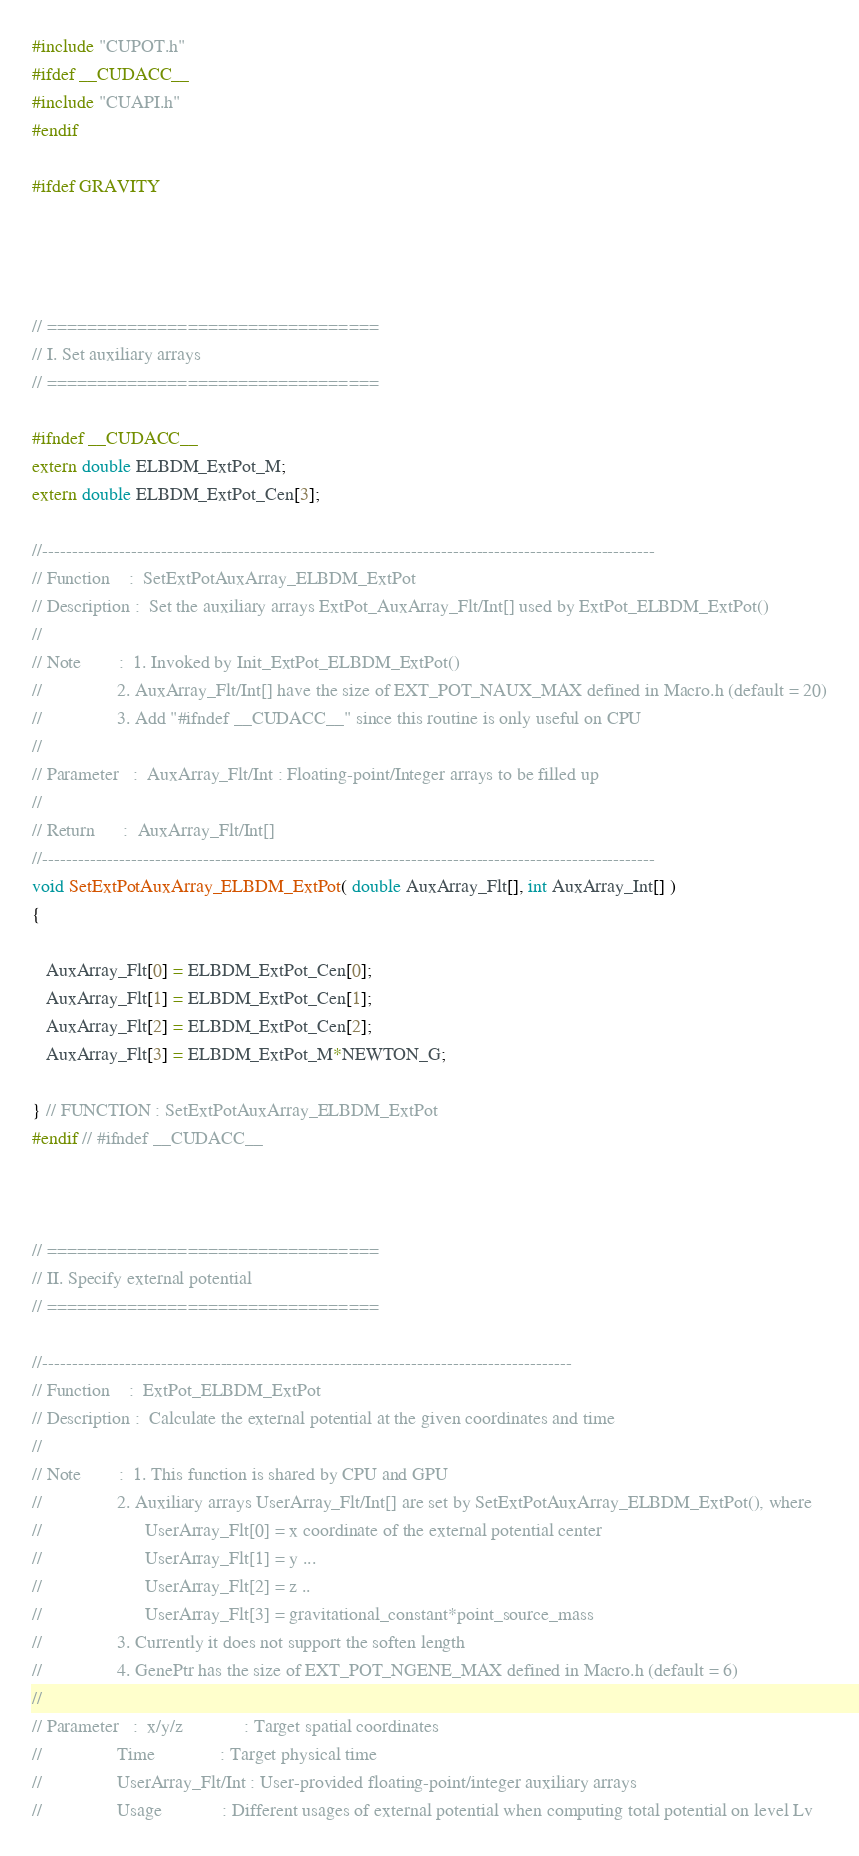Convert code to text. <code><loc_0><loc_0><loc_500><loc_500><_Cuda_>#include "CUPOT.h"
#ifdef __CUDACC__
#include "CUAPI.h"
#endif

#ifdef GRAVITY




// =================================
// I. Set auxiliary arrays
// =================================

#ifndef __CUDACC__
extern double ELBDM_ExtPot_M;
extern double ELBDM_ExtPot_Cen[3];

//-------------------------------------------------------------------------------------------------------
// Function    :  SetExtPotAuxArray_ELBDM_ExtPot
// Description :  Set the auxiliary arrays ExtPot_AuxArray_Flt/Int[] used by ExtPot_ELBDM_ExtPot()
//
// Note        :  1. Invoked by Init_ExtPot_ELBDM_ExtPot()
//                2. AuxArray_Flt/Int[] have the size of EXT_POT_NAUX_MAX defined in Macro.h (default = 20)
//                3. Add "#ifndef __CUDACC__" since this routine is only useful on CPU
//
// Parameter   :  AuxArray_Flt/Int : Floating-point/Integer arrays to be filled up
//
// Return      :  AuxArray_Flt/Int[]
//-------------------------------------------------------------------------------------------------------
void SetExtPotAuxArray_ELBDM_ExtPot( double AuxArray_Flt[], int AuxArray_Int[] )
{

   AuxArray_Flt[0] = ELBDM_ExtPot_Cen[0];
   AuxArray_Flt[1] = ELBDM_ExtPot_Cen[1];
   AuxArray_Flt[2] = ELBDM_ExtPot_Cen[2];
   AuxArray_Flt[3] = ELBDM_ExtPot_M*NEWTON_G;

} // FUNCTION : SetExtPotAuxArray_ELBDM_ExtPot
#endif // #ifndef __CUDACC__



// =================================
// II. Specify external potential
// =================================

//-----------------------------------------------------------------------------------------
// Function    :  ExtPot_ELBDM_ExtPot
// Description :  Calculate the external potential at the given coordinates and time
//
// Note        :  1. This function is shared by CPU and GPU
//                2. Auxiliary arrays UserArray_Flt/Int[] are set by SetExtPotAuxArray_ELBDM_ExtPot(), where
//                      UserArray_Flt[0] = x coordinate of the external potential center
//                      UserArray_Flt[1] = y ...
//                      UserArray_Flt[2] = z ..
//                      UserArray_Flt[3] = gravitational_constant*point_source_mass
//                3. Currently it does not support the soften length
//                4. GenePtr has the size of EXT_POT_NGENE_MAX defined in Macro.h (default = 6)
//
// Parameter   :  x/y/z             : Target spatial coordinates
//                Time              : Target physical time
//                UserArray_Flt/Int : User-provided floating-point/integer auxiliary arrays
//                Usage             : Different usages of external potential when computing total potential on level Lv</code> 